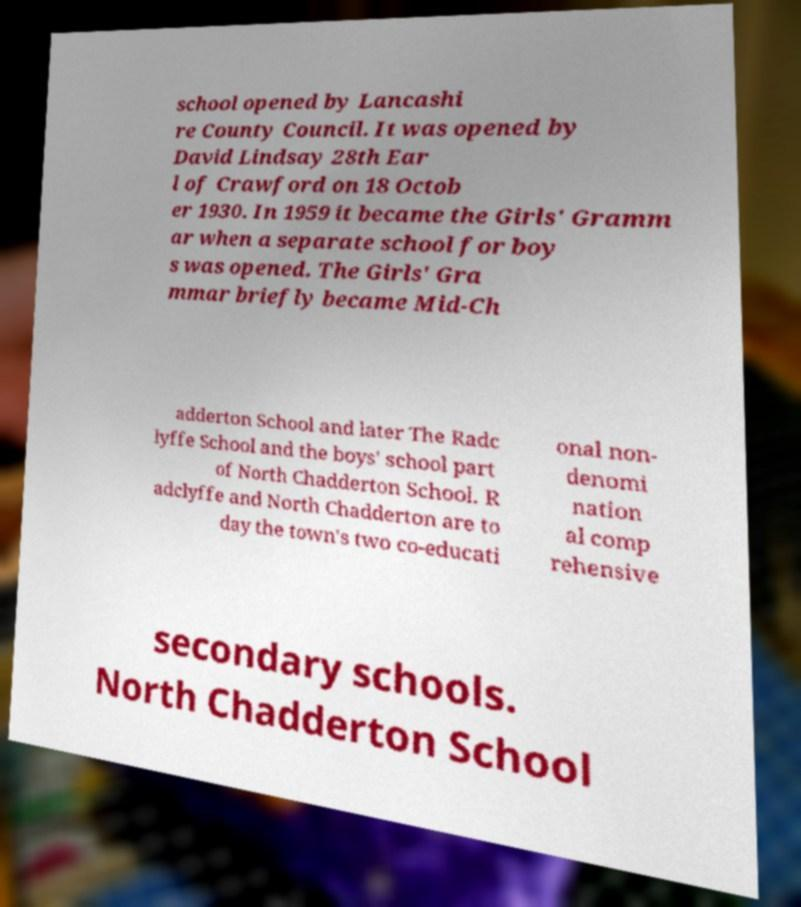Please read and relay the text visible in this image. What does it say? school opened by Lancashi re County Council. It was opened by David Lindsay 28th Ear l of Crawford on 18 Octob er 1930. In 1959 it became the Girls' Gramm ar when a separate school for boy s was opened. The Girls' Gra mmar briefly became Mid-Ch adderton School and later The Radc lyffe School and the boys' school part of North Chadderton School. R adclyffe and North Chadderton are to day the town's two co-educati onal non- denomi nation al comp rehensive secondary schools. North Chadderton School 